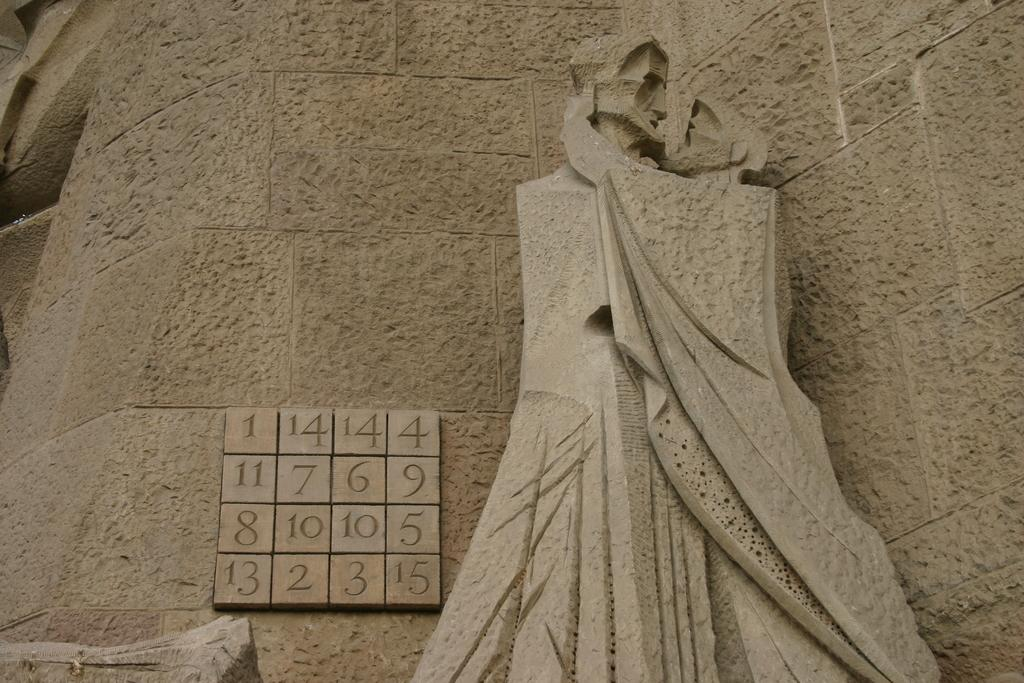What is the main subject in the image? There is a statue in the image. Are there any additional elements or details near the statue? Yes, there are numbers beside the statue. Is the statue sinking into quicksand in the image? No, there is no quicksand present in the image, and the statue is not sinking. Are the numbers beside the statue part of a recess or classroom setting? The image does not provide any information about a recess or classroom setting, so it cannot be determined if the numbers are related to such an environment. 